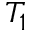<formula> <loc_0><loc_0><loc_500><loc_500>T _ { 1 }</formula> 